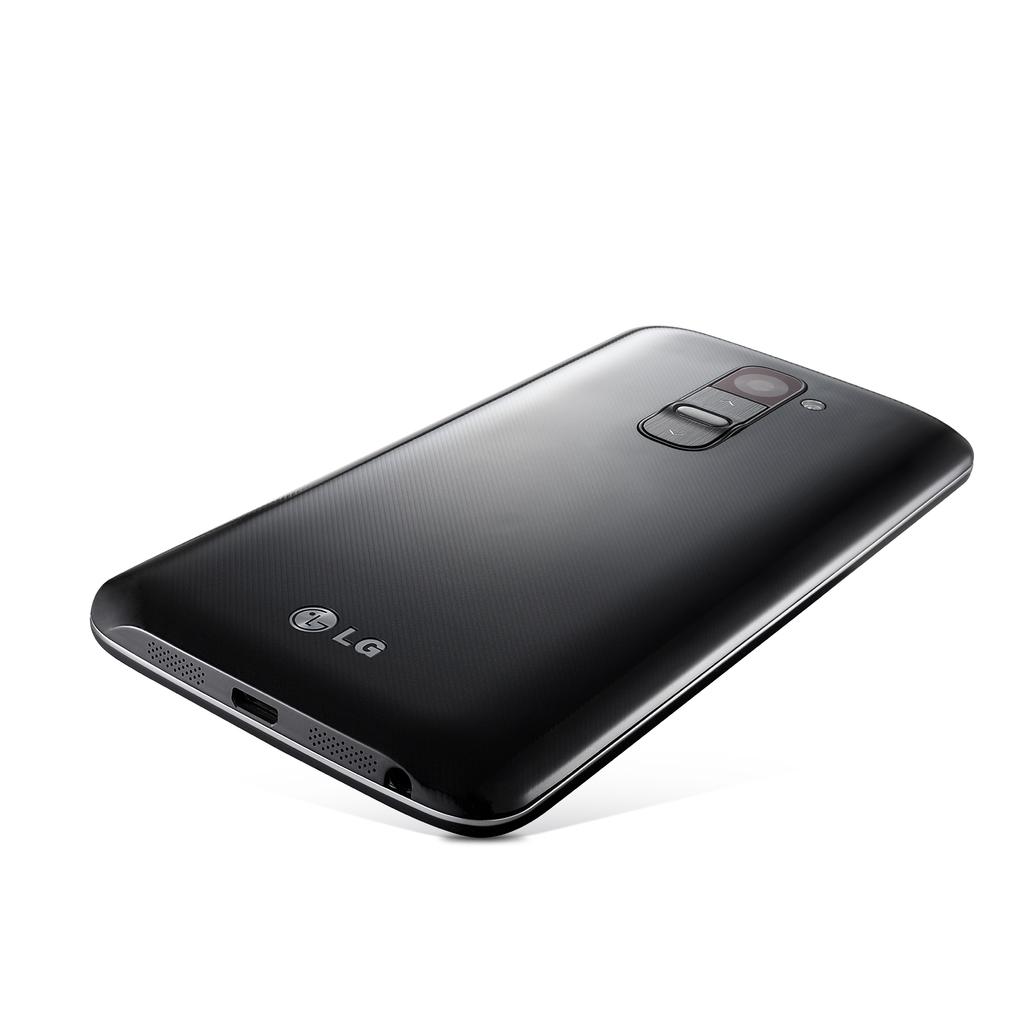Who makes this phone?
Keep it short and to the point. Lg. 